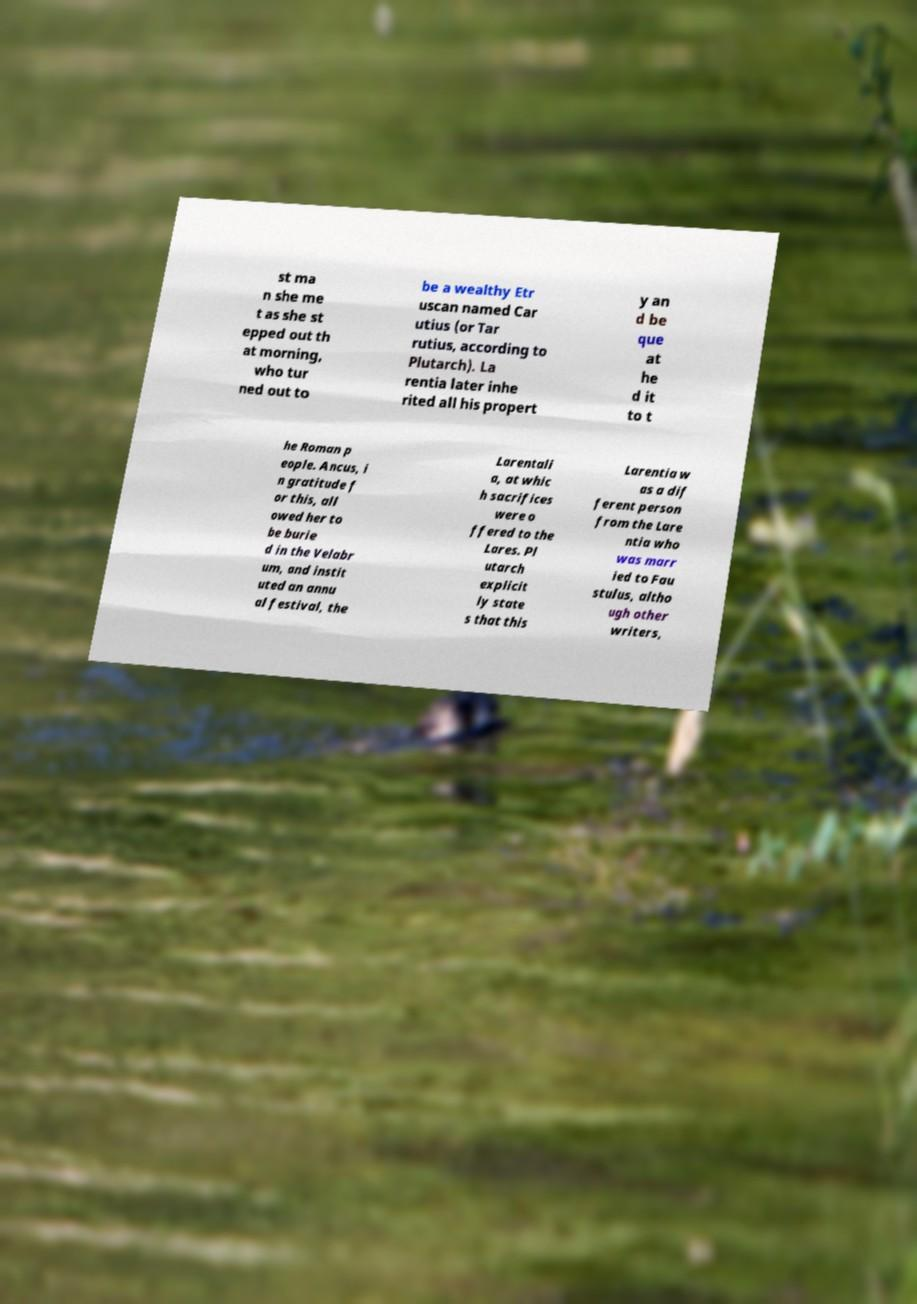Can you read and provide the text displayed in the image?This photo seems to have some interesting text. Can you extract and type it out for me? st ma n she me t as she st epped out th at morning, who tur ned out to be a wealthy Etr uscan named Car utius (or Tar rutius, according to Plutarch). La rentia later inhe rited all his propert y an d be que at he d it to t he Roman p eople. Ancus, i n gratitude f or this, all owed her to be burie d in the Velabr um, and instit uted an annu al festival, the Larentali a, at whic h sacrifices were o ffered to the Lares. Pl utarch explicit ly state s that this Larentia w as a dif ferent person from the Lare ntia who was marr ied to Fau stulus, altho ugh other writers, 